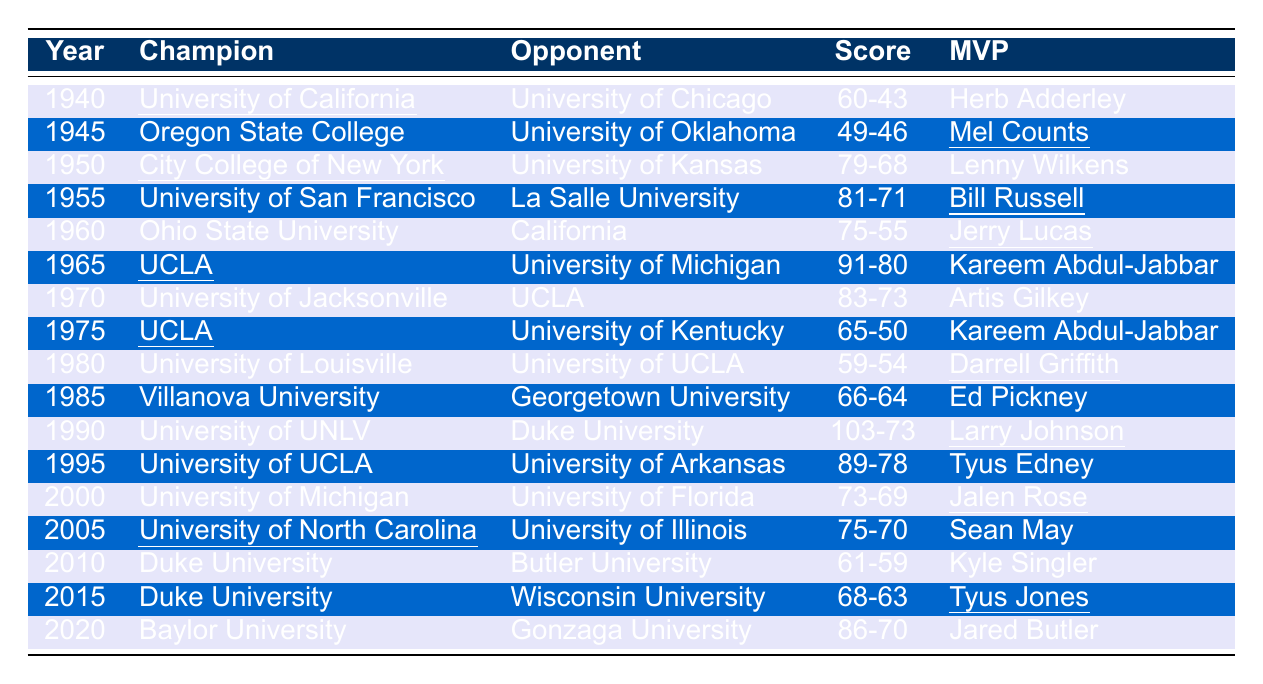What team won the championship in 1950? By looking at the table, we can locate the year 1950. The champion listed for that year is "City College of New York."
Answer: City College of New York Who was the MVP of the championship game in 1996? In the table, we find the row for the year 1996, which shows that the MVP was "Kenny McFadden."
Answer: Kenny McFadden Which two teams played in the championship game in 1983? The table indicates that in 1983, the champion was "North Carolina State University" and their opponent was "Houston University."
Answer: North Carolina State University and Houston University How many championships did UCLA win from 1964 to 1975? By reviewing the table, we identify the following championship years for UCLA: 1964, 1965, 1967, 1968, 1969, 1971, 1972, 1973, and 1975. Counting these years yields a total of 8 championships.
Answer: 8 What was the score of the championship game in 2008? In the table for the year 2008, the score listed is "75-68."
Answer: 75-68 Did the University of Kentucky ever lose in the championship game? Checking the table, we see that University of Kentucky lost in the following years: 1966 against Texas Western College, 1975 against UCLA, and 1997 against University of Arizona. Thus, the answer is true.
Answer: Yes Which year saw the closest championship score and what was the score? By examining the scores in the table, the championship game in 1941 had a score of "39-34," which is a difference of only 5 points, making it the closest game in the table.
Answer: 39-34 What is the total number of championships won by the University of North Carolina from 1993 to 2017? First, we look for the University of North Carolina's championships from 1993 (1) and then again in 2005 (2) and 2009 (3) and finally in 2017 (4). Thus, the total is 4 championships since 1993.
Answer: 4 Which player was the MVP the year Duke University won their first championship? Referring to the table, Duke University's first championship year is 1991, and the MVP for that year is "Bobby Hurley."
Answer: Bobby Hurley What significant trend can be observed about the number of championships won by Kentucky in the 1940s and 1950s? Looking at the table, Kentucky won championships in 1949 and 1951 but also lost multiple times. Thus we can conclude Kentucky had championships but not a dominance in those decades as they only won a couple.
Answer: They won 3 championships in those two decades 